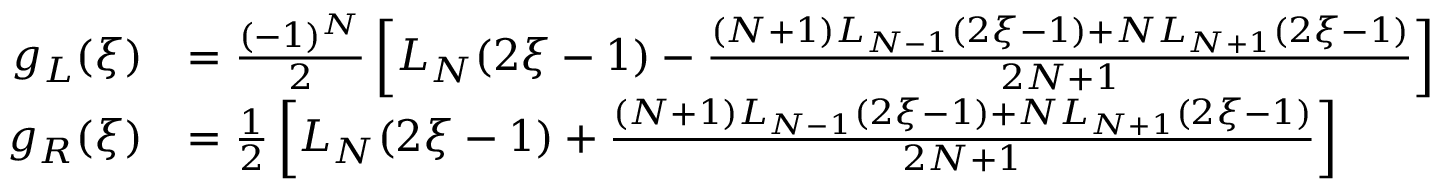<formula> <loc_0><loc_0><loc_500><loc_500>\begin{array} { r l } { g _ { L } ( \xi ) } & { = \frac { ( - 1 ) ^ { N } } { 2 } \left [ L _ { N } ( 2 \xi - 1 ) - \frac { ( N + 1 ) L _ { N - 1 } ( 2 \xi - 1 ) + N L _ { N + 1 } ( 2 \xi - 1 ) } { 2 N + 1 } \right ] } \\ { g _ { R } ( \xi ) } & { = \frac { 1 } { 2 } \left [ L _ { N } ( 2 \xi - 1 ) + \frac { ( N + 1 ) L _ { N - 1 } ( 2 \xi - 1 ) + N L _ { N + 1 } ( 2 \xi - 1 ) } { 2 N + 1 } \right ] } \end{array}</formula> 